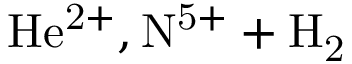<formula> <loc_0><loc_0><loc_500><loc_500>H e ^ { 2 + } , N ^ { 5 + } + H _ { 2 }</formula> 